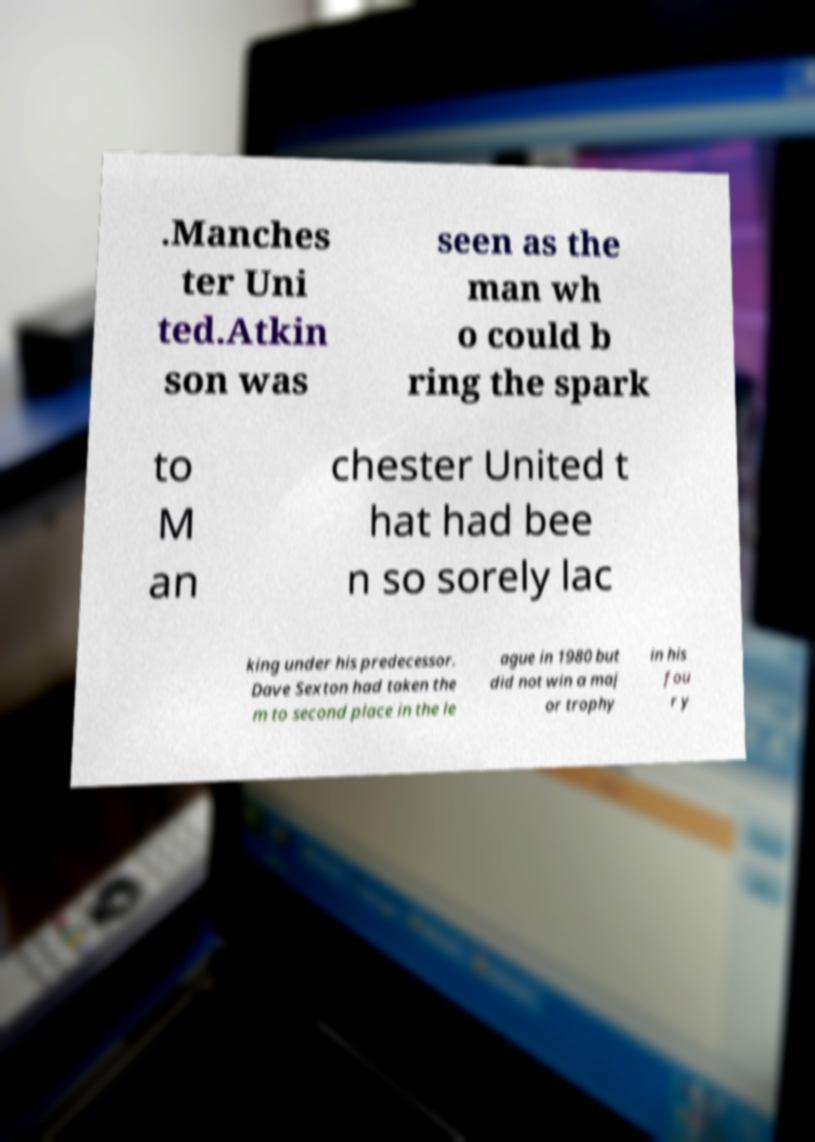Please identify and transcribe the text found in this image. .Manches ter Uni ted.Atkin son was seen as the man wh o could b ring the spark to M an chester United t hat had bee n so sorely lac king under his predecessor. Dave Sexton had taken the m to second place in the le ague in 1980 but did not win a maj or trophy in his fou r y 